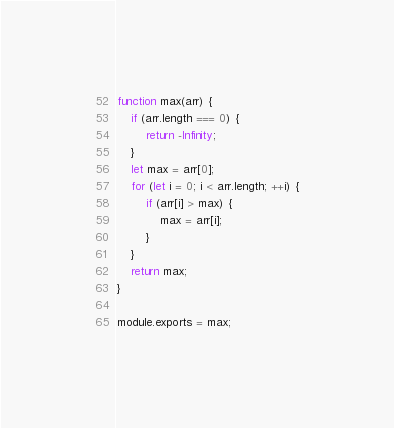<code> <loc_0><loc_0><loc_500><loc_500><_JavaScript_>function max(arr) {
    if (arr.length === 0) {
        return -Infinity;
    }
    let max = arr[0];
    for (let i = 0; i < arr.length; ++i) {
        if (arr[i] > max) {
            max = arr[i];
        }
    }
    return max;
}

module.exports = max;</code> 